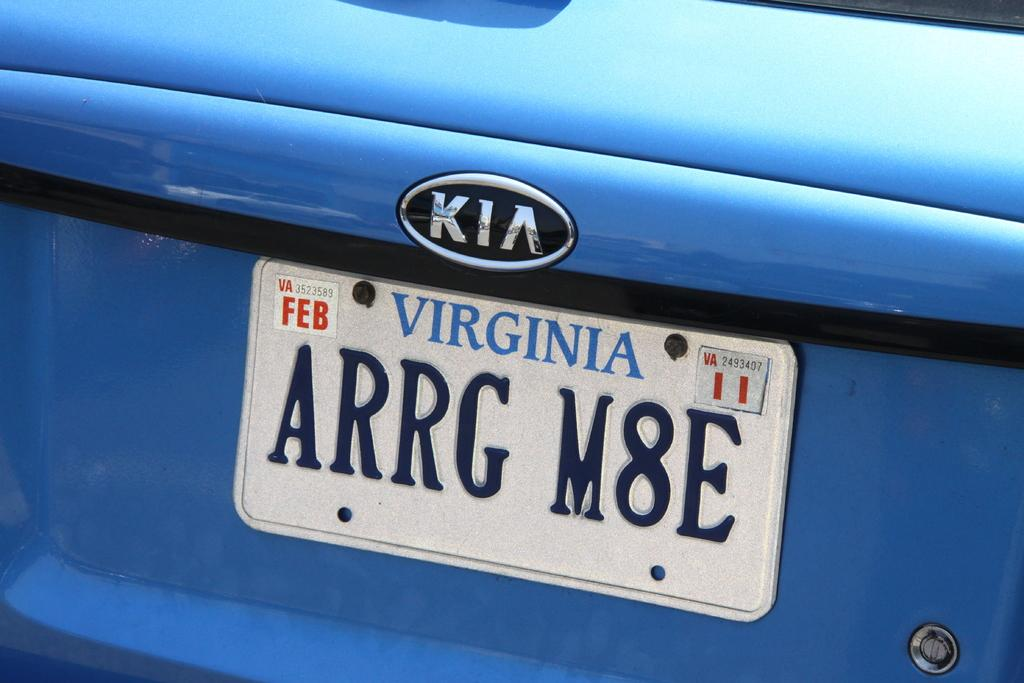<image>
Give a short and clear explanation of the subsequent image. White Virginia license plate which says ARRGM8E on it. 